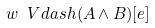Convert formula to latex. <formula><loc_0><loc_0><loc_500><loc_500>w \ V d a s h ( A \wedge B ) [ e ]</formula> 